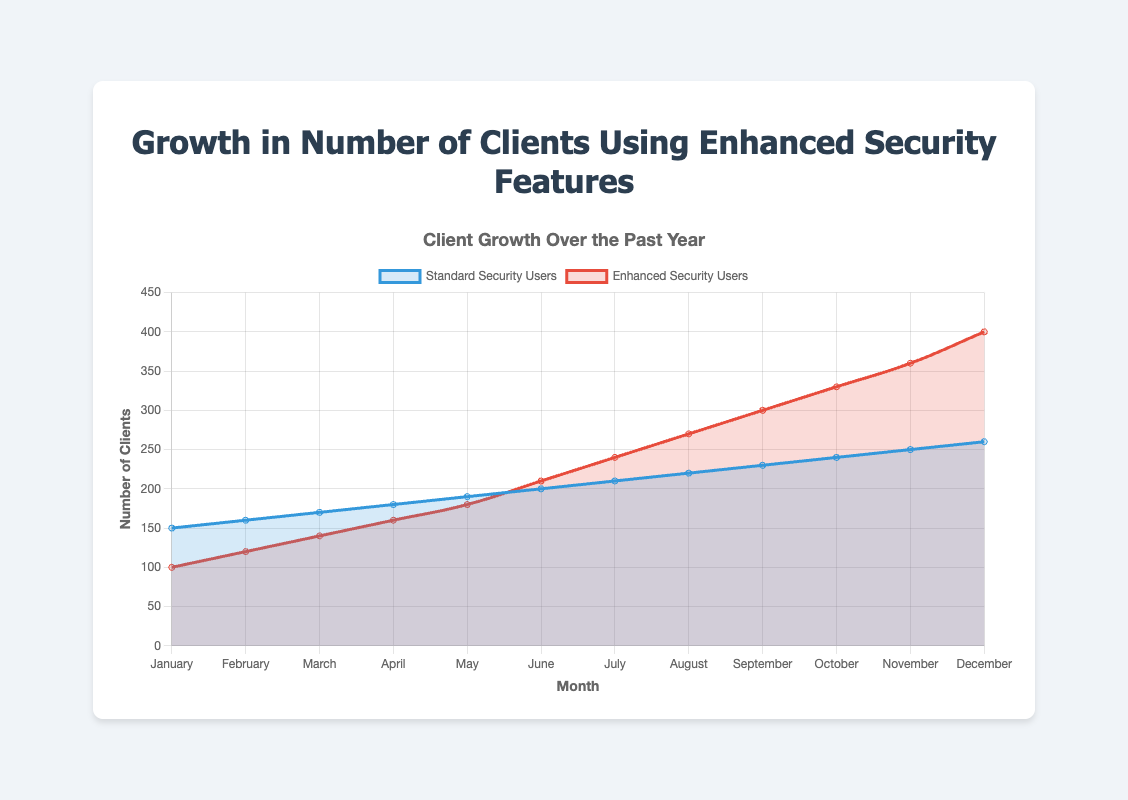What is the total number of clients using enhanced security features in the first half of the year? To find the total number of clients using enhanced security features in the first half (January to June), add the values: 100 (Jan) + 120 (Feb) + 140 (Mar) + 160 (Apr) + 180 (May) + 210 (Jun) = 910
Answer: 910 In which month did enhanced security users surpass standard security users for the first time? By examining the plot lines, we see that in June, the number of enhanced security users (210) surpassed the number of standard security users (200) for the first time.
Answer: June What is the difference in the number of standard security users between January and December? Subtract the number of standard security users in January from the number in December: 260 (Dec) - 150 (Jan) = 110
Answer: 110 By how much did the number of clients using enhanced security features increase in November compared to October? Subtract the number of enhanced security users in October from the number in November: 360 (Nov) - 330 (Oct) = 30
Answer: 30 Which month had the highest increase in the number of enhanced security users compared to the previous month? To find the month with the highest increase, calculate the monthly differences: Feb-Jan (20), Mar-Feb (20), Apr-Mar (20), May-Apr (20), Jun-May (30), Jul-Jun (30), Aug-Jul (30), Sep-Aug (30), Oct-Sep (30), Nov-Oct (30), Dec-Nov (40). December had the highest increase (40).
Answer: December Compare the growth trend of standard security users to enhanced security users across the year. Which trend is steeper? Observing the slopes of both curves, the enhanced security users' curve rises more steeply than the standard security users' curve, indicating a higher growth rate.
Answer: Enhanced security users How many clients in total were using either type of security in June? Add the number of standard security users and enhanced security users in June: 200 + 210 = 410
Answer: 410 Describe the visual difference in the plot lines for standard security users and enhanced security users. The plot line for standard security users has a slower and more gradual increase, colored in blue with a lighter fill, while the plot line for enhanced security users shows a steeper increase, colored in red with a light red fill.
Answer: Standard: gradual, blue; Enhanced: steep, red What is the average number of enhanced security users from July to December? First, sum the values from July to December: 240 (Jul) + 270 (Aug) + 300 (Sep) + 330 (Oct) + 360 (Nov) + 400 (Dec) = 1900. Then divide by 6 months: 1900 / 6 ≈ 317
Answer: 317 By how much did the number of standard security users increase on average each month over the year? Calculate the difference over the year: 260 (Dec) - 150 (Jan) = 110. Then divide by 11 months (as we measure increases between months): 110 / 11 = 10
Answer: 10 